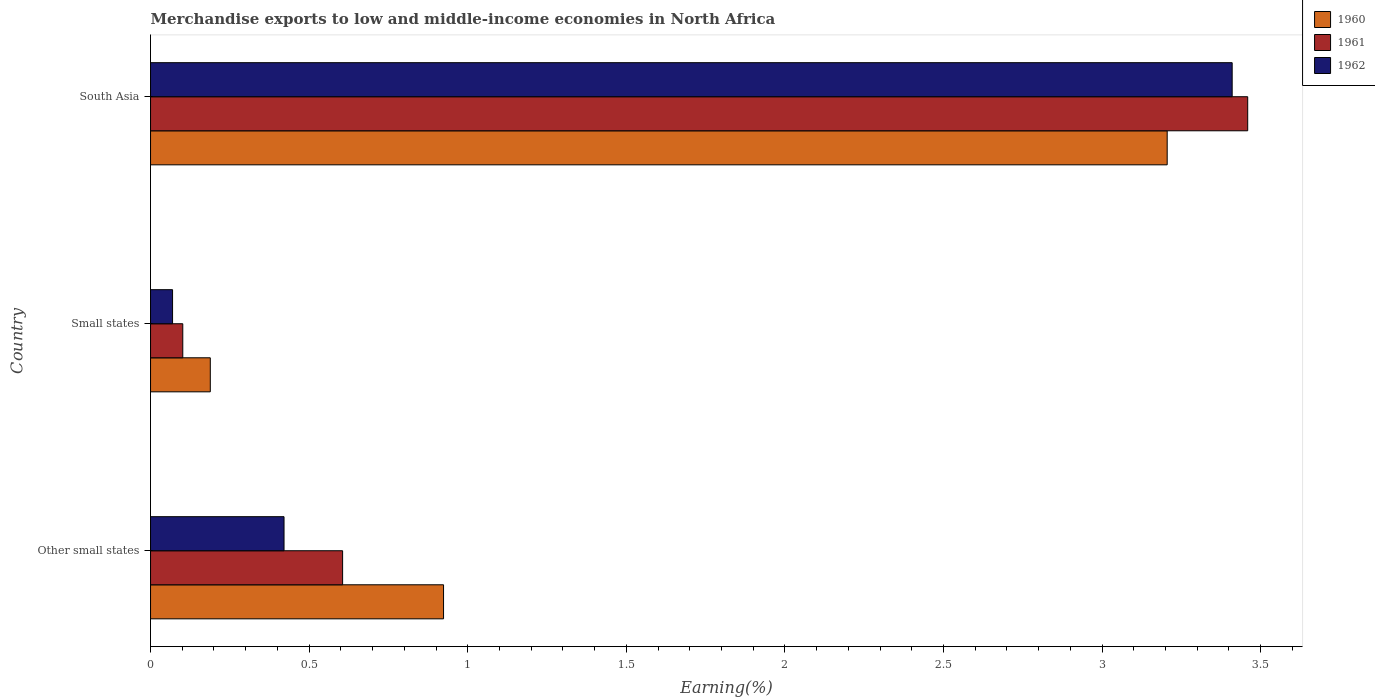How many different coloured bars are there?
Give a very brief answer. 3. Are the number of bars per tick equal to the number of legend labels?
Provide a short and direct response. Yes. How many bars are there on the 3rd tick from the bottom?
Offer a terse response. 3. What is the label of the 3rd group of bars from the top?
Make the answer very short. Other small states. In how many cases, is the number of bars for a given country not equal to the number of legend labels?
Provide a short and direct response. 0. What is the percentage of amount earned from merchandise exports in 1961 in South Asia?
Your response must be concise. 3.46. Across all countries, what is the maximum percentage of amount earned from merchandise exports in 1961?
Make the answer very short. 3.46. Across all countries, what is the minimum percentage of amount earned from merchandise exports in 1960?
Your response must be concise. 0.19. In which country was the percentage of amount earned from merchandise exports in 1962 minimum?
Make the answer very short. Small states. What is the total percentage of amount earned from merchandise exports in 1962 in the graph?
Give a very brief answer. 3.9. What is the difference between the percentage of amount earned from merchandise exports in 1961 in Small states and that in South Asia?
Give a very brief answer. -3.36. What is the difference between the percentage of amount earned from merchandise exports in 1960 in Other small states and the percentage of amount earned from merchandise exports in 1961 in Small states?
Provide a succinct answer. 0.82. What is the average percentage of amount earned from merchandise exports in 1962 per country?
Your answer should be very brief. 1.3. What is the difference between the percentage of amount earned from merchandise exports in 1960 and percentage of amount earned from merchandise exports in 1961 in Other small states?
Give a very brief answer. 0.32. In how many countries, is the percentage of amount earned from merchandise exports in 1961 greater than 0.4 %?
Provide a short and direct response. 2. What is the ratio of the percentage of amount earned from merchandise exports in 1962 in Other small states to that in Small states?
Your answer should be compact. 6.06. Is the difference between the percentage of amount earned from merchandise exports in 1960 in Other small states and Small states greater than the difference between the percentage of amount earned from merchandise exports in 1961 in Other small states and Small states?
Make the answer very short. Yes. What is the difference between the highest and the second highest percentage of amount earned from merchandise exports in 1960?
Offer a terse response. 2.28. What is the difference between the highest and the lowest percentage of amount earned from merchandise exports in 1961?
Give a very brief answer. 3.36. In how many countries, is the percentage of amount earned from merchandise exports in 1961 greater than the average percentage of amount earned from merchandise exports in 1961 taken over all countries?
Provide a short and direct response. 1. Is the sum of the percentage of amount earned from merchandise exports in 1961 in Other small states and Small states greater than the maximum percentage of amount earned from merchandise exports in 1960 across all countries?
Offer a terse response. No. What does the 1st bar from the top in Other small states represents?
Your answer should be very brief. 1962. What does the 3rd bar from the bottom in South Asia represents?
Provide a succinct answer. 1962. Is it the case that in every country, the sum of the percentage of amount earned from merchandise exports in 1962 and percentage of amount earned from merchandise exports in 1960 is greater than the percentage of amount earned from merchandise exports in 1961?
Your answer should be very brief. Yes. How many bars are there?
Keep it short and to the point. 9. What is the difference between two consecutive major ticks on the X-axis?
Offer a very short reply. 0.5. Are the values on the major ticks of X-axis written in scientific E-notation?
Provide a succinct answer. No. Does the graph contain grids?
Your answer should be very brief. No. Where does the legend appear in the graph?
Keep it short and to the point. Top right. How many legend labels are there?
Ensure brevity in your answer.  3. How are the legend labels stacked?
Your response must be concise. Vertical. What is the title of the graph?
Your answer should be very brief. Merchandise exports to low and middle-income economies in North Africa. Does "2009" appear as one of the legend labels in the graph?
Ensure brevity in your answer.  No. What is the label or title of the X-axis?
Keep it short and to the point. Earning(%). What is the label or title of the Y-axis?
Offer a terse response. Country. What is the Earning(%) of 1960 in Other small states?
Your answer should be very brief. 0.92. What is the Earning(%) in 1961 in Other small states?
Ensure brevity in your answer.  0.61. What is the Earning(%) in 1962 in Other small states?
Ensure brevity in your answer.  0.42. What is the Earning(%) in 1960 in Small states?
Your response must be concise. 0.19. What is the Earning(%) of 1961 in Small states?
Your response must be concise. 0.1. What is the Earning(%) of 1962 in Small states?
Your answer should be compact. 0.07. What is the Earning(%) in 1960 in South Asia?
Your answer should be very brief. 3.21. What is the Earning(%) of 1961 in South Asia?
Make the answer very short. 3.46. What is the Earning(%) of 1962 in South Asia?
Make the answer very short. 3.41. Across all countries, what is the maximum Earning(%) of 1960?
Provide a short and direct response. 3.21. Across all countries, what is the maximum Earning(%) in 1961?
Make the answer very short. 3.46. Across all countries, what is the maximum Earning(%) in 1962?
Provide a succinct answer. 3.41. Across all countries, what is the minimum Earning(%) in 1960?
Give a very brief answer. 0.19. Across all countries, what is the minimum Earning(%) of 1961?
Ensure brevity in your answer.  0.1. Across all countries, what is the minimum Earning(%) in 1962?
Keep it short and to the point. 0.07. What is the total Earning(%) in 1960 in the graph?
Give a very brief answer. 4.32. What is the total Earning(%) of 1961 in the graph?
Your response must be concise. 4.17. What is the total Earning(%) of 1962 in the graph?
Your response must be concise. 3.9. What is the difference between the Earning(%) of 1960 in Other small states and that in Small states?
Offer a very short reply. 0.74. What is the difference between the Earning(%) in 1961 in Other small states and that in Small states?
Your answer should be very brief. 0.5. What is the difference between the Earning(%) of 1962 in Other small states and that in Small states?
Your answer should be very brief. 0.35. What is the difference between the Earning(%) in 1960 in Other small states and that in South Asia?
Your answer should be compact. -2.28. What is the difference between the Earning(%) of 1961 in Other small states and that in South Asia?
Your answer should be very brief. -2.85. What is the difference between the Earning(%) of 1962 in Other small states and that in South Asia?
Offer a very short reply. -2.99. What is the difference between the Earning(%) of 1960 in Small states and that in South Asia?
Give a very brief answer. -3.02. What is the difference between the Earning(%) in 1961 in Small states and that in South Asia?
Give a very brief answer. -3.36. What is the difference between the Earning(%) of 1962 in Small states and that in South Asia?
Offer a very short reply. -3.34. What is the difference between the Earning(%) in 1960 in Other small states and the Earning(%) in 1961 in Small states?
Give a very brief answer. 0.82. What is the difference between the Earning(%) in 1960 in Other small states and the Earning(%) in 1962 in Small states?
Offer a terse response. 0.85. What is the difference between the Earning(%) of 1961 in Other small states and the Earning(%) of 1962 in Small states?
Keep it short and to the point. 0.54. What is the difference between the Earning(%) in 1960 in Other small states and the Earning(%) in 1961 in South Asia?
Provide a succinct answer. -2.54. What is the difference between the Earning(%) of 1960 in Other small states and the Earning(%) of 1962 in South Asia?
Give a very brief answer. -2.49. What is the difference between the Earning(%) of 1961 in Other small states and the Earning(%) of 1962 in South Asia?
Provide a short and direct response. -2.8. What is the difference between the Earning(%) of 1960 in Small states and the Earning(%) of 1961 in South Asia?
Keep it short and to the point. -3.27. What is the difference between the Earning(%) of 1960 in Small states and the Earning(%) of 1962 in South Asia?
Your answer should be compact. -3.22. What is the difference between the Earning(%) in 1961 in Small states and the Earning(%) in 1962 in South Asia?
Provide a succinct answer. -3.31. What is the average Earning(%) in 1960 per country?
Give a very brief answer. 1.44. What is the average Earning(%) of 1961 per country?
Give a very brief answer. 1.39. What is the average Earning(%) of 1962 per country?
Provide a short and direct response. 1.3. What is the difference between the Earning(%) of 1960 and Earning(%) of 1961 in Other small states?
Provide a succinct answer. 0.32. What is the difference between the Earning(%) in 1960 and Earning(%) in 1962 in Other small states?
Keep it short and to the point. 0.5. What is the difference between the Earning(%) in 1961 and Earning(%) in 1962 in Other small states?
Your answer should be very brief. 0.18. What is the difference between the Earning(%) of 1960 and Earning(%) of 1961 in Small states?
Your answer should be compact. 0.09. What is the difference between the Earning(%) in 1960 and Earning(%) in 1962 in Small states?
Give a very brief answer. 0.12. What is the difference between the Earning(%) in 1961 and Earning(%) in 1962 in Small states?
Give a very brief answer. 0.03. What is the difference between the Earning(%) of 1960 and Earning(%) of 1961 in South Asia?
Give a very brief answer. -0.25. What is the difference between the Earning(%) in 1960 and Earning(%) in 1962 in South Asia?
Make the answer very short. -0.2. What is the difference between the Earning(%) of 1961 and Earning(%) of 1962 in South Asia?
Make the answer very short. 0.05. What is the ratio of the Earning(%) of 1960 in Other small states to that in Small states?
Give a very brief answer. 4.9. What is the ratio of the Earning(%) in 1961 in Other small states to that in Small states?
Provide a succinct answer. 5.96. What is the ratio of the Earning(%) in 1962 in Other small states to that in Small states?
Your answer should be compact. 6.06. What is the ratio of the Earning(%) in 1960 in Other small states to that in South Asia?
Give a very brief answer. 0.29. What is the ratio of the Earning(%) in 1961 in Other small states to that in South Asia?
Your answer should be very brief. 0.18. What is the ratio of the Earning(%) in 1962 in Other small states to that in South Asia?
Make the answer very short. 0.12. What is the ratio of the Earning(%) in 1960 in Small states to that in South Asia?
Offer a terse response. 0.06. What is the ratio of the Earning(%) in 1961 in Small states to that in South Asia?
Your response must be concise. 0.03. What is the ratio of the Earning(%) of 1962 in Small states to that in South Asia?
Offer a terse response. 0.02. What is the difference between the highest and the second highest Earning(%) of 1960?
Your answer should be very brief. 2.28. What is the difference between the highest and the second highest Earning(%) in 1961?
Your answer should be compact. 2.85. What is the difference between the highest and the second highest Earning(%) in 1962?
Make the answer very short. 2.99. What is the difference between the highest and the lowest Earning(%) in 1960?
Your answer should be very brief. 3.02. What is the difference between the highest and the lowest Earning(%) of 1961?
Offer a terse response. 3.36. What is the difference between the highest and the lowest Earning(%) in 1962?
Provide a succinct answer. 3.34. 